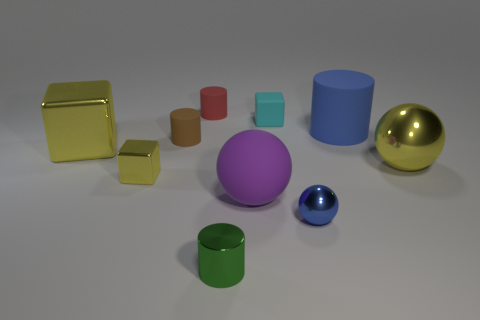Subtract all cylinders. How many objects are left? 6 Add 2 large blue rubber balls. How many large blue rubber balls exist? 2 Subtract 0 purple cylinders. How many objects are left? 10 Subtract all large things. Subtract all tiny green shiny objects. How many objects are left? 5 Add 2 big purple objects. How many big purple objects are left? 3 